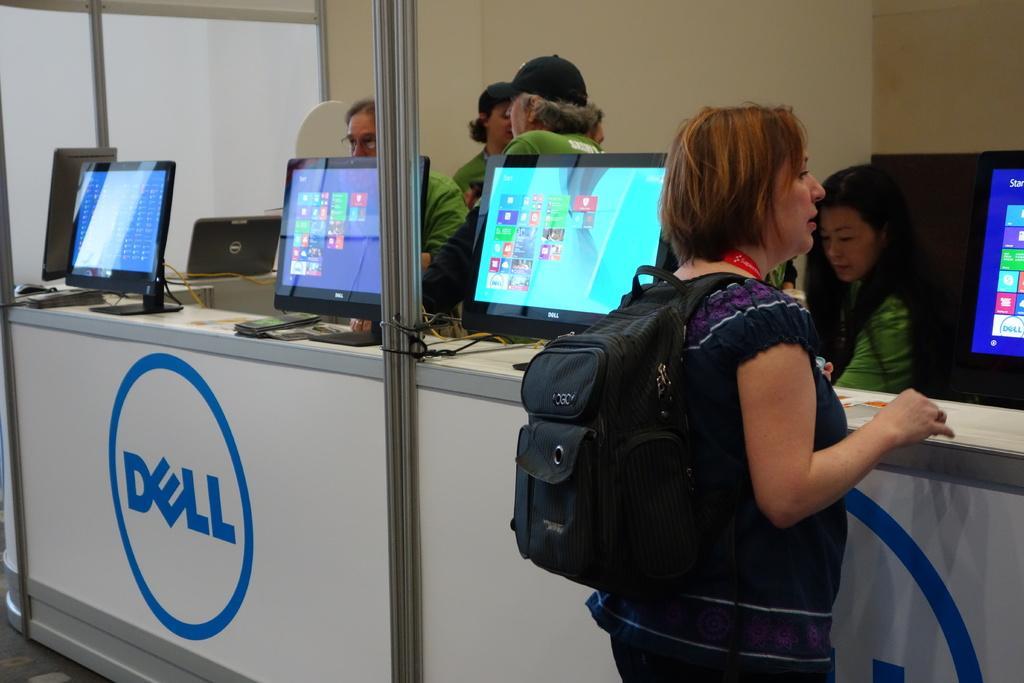How would you summarize this image in a sentence or two? In the image there are desktops on the table and in front of the desktops there is a woman standing and behind the desktops there are few people, in the background there is a wall. 